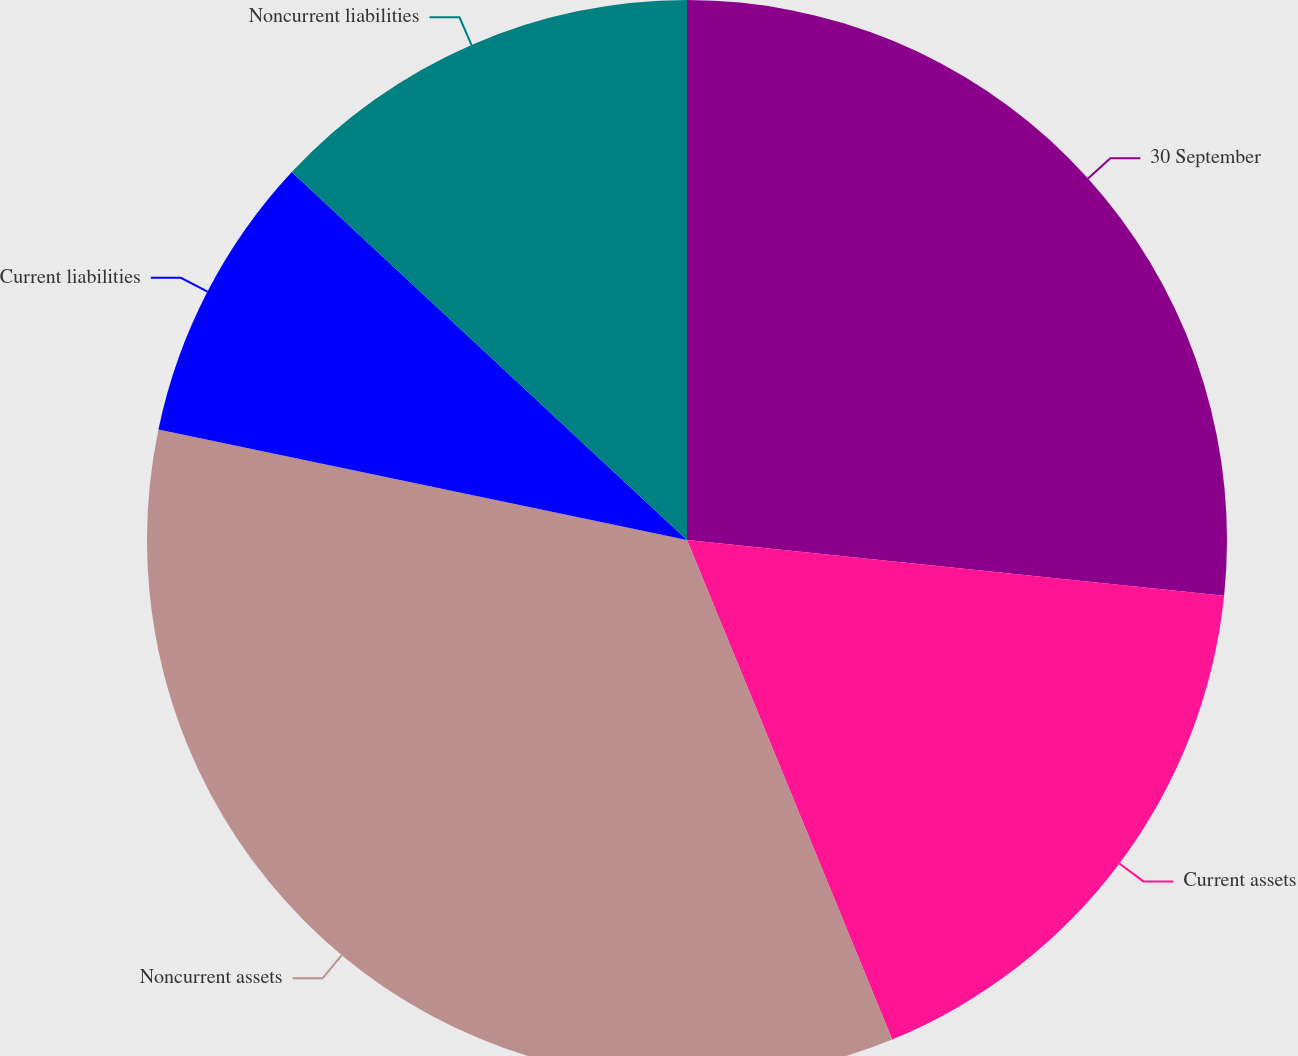Convert chart to OTSL. <chart><loc_0><loc_0><loc_500><loc_500><pie_chart><fcel>30 September<fcel>Current assets<fcel>Noncurrent assets<fcel>Current liabilities<fcel>Noncurrent liabilities<nl><fcel>26.65%<fcel>17.15%<fcel>34.49%<fcel>8.65%<fcel>13.07%<nl></chart> 